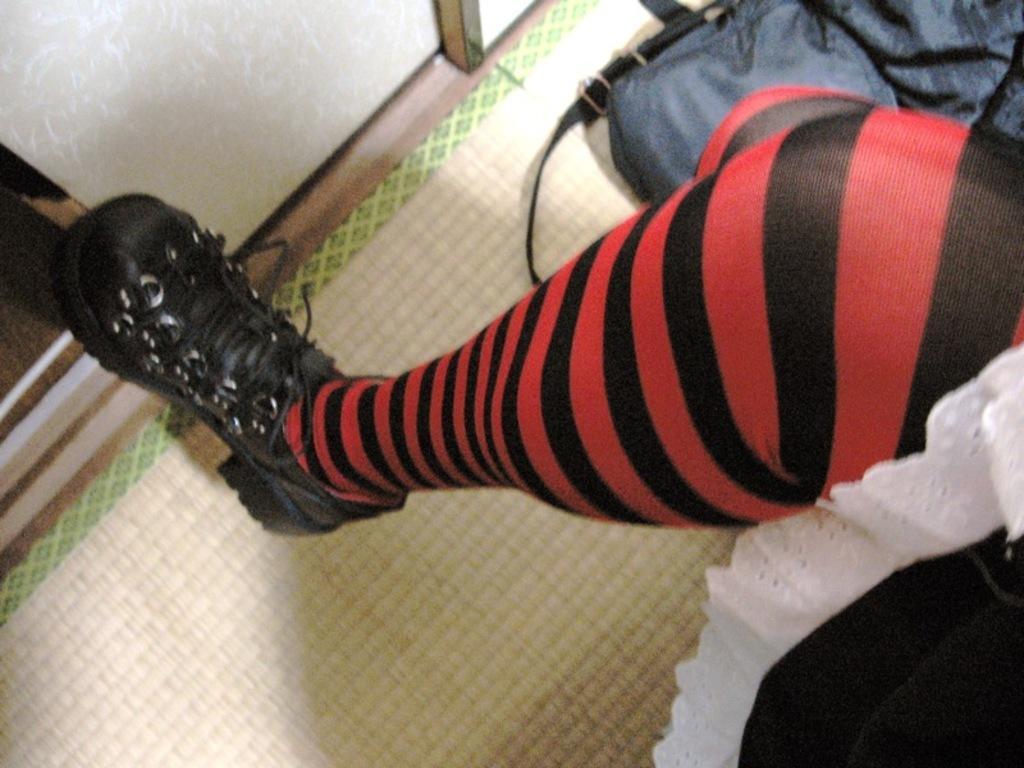Can you describe this image briefly? In the foreground of the picture there is a person's leg. At the top there is a bag. On the left it is door. 